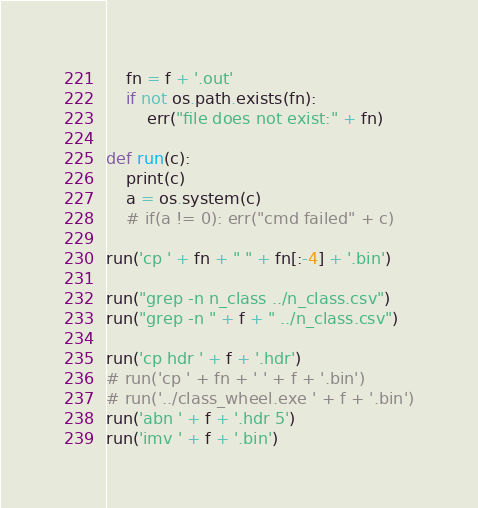Convert code to text. <code><loc_0><loc_0><loc_500><loc_500><_Python_>    fn = f + '.out'
    if not os.path.exists(fn):
        err("file does not exist:" + fn)

def run(c):
    print(c)
    a = os.system(c)
    # if(a != 0): err("cmd failed" + c)

run('cp ' + fn + " " + fn[:-4] + '.bin')

run("grep -n n_class ../n_class.csv")
run("grep -n " + f + " ../n_class.csv")

run('cp hdr ' + f + '.hdr')
# run('cp ' + fn + ' ' + f + '.bin')
# run('../class_wheel.exe ' + f + '.bin')
run('abn ' + f + '.hdr 5')
run('imv ' + f + '.bin')
</code> 